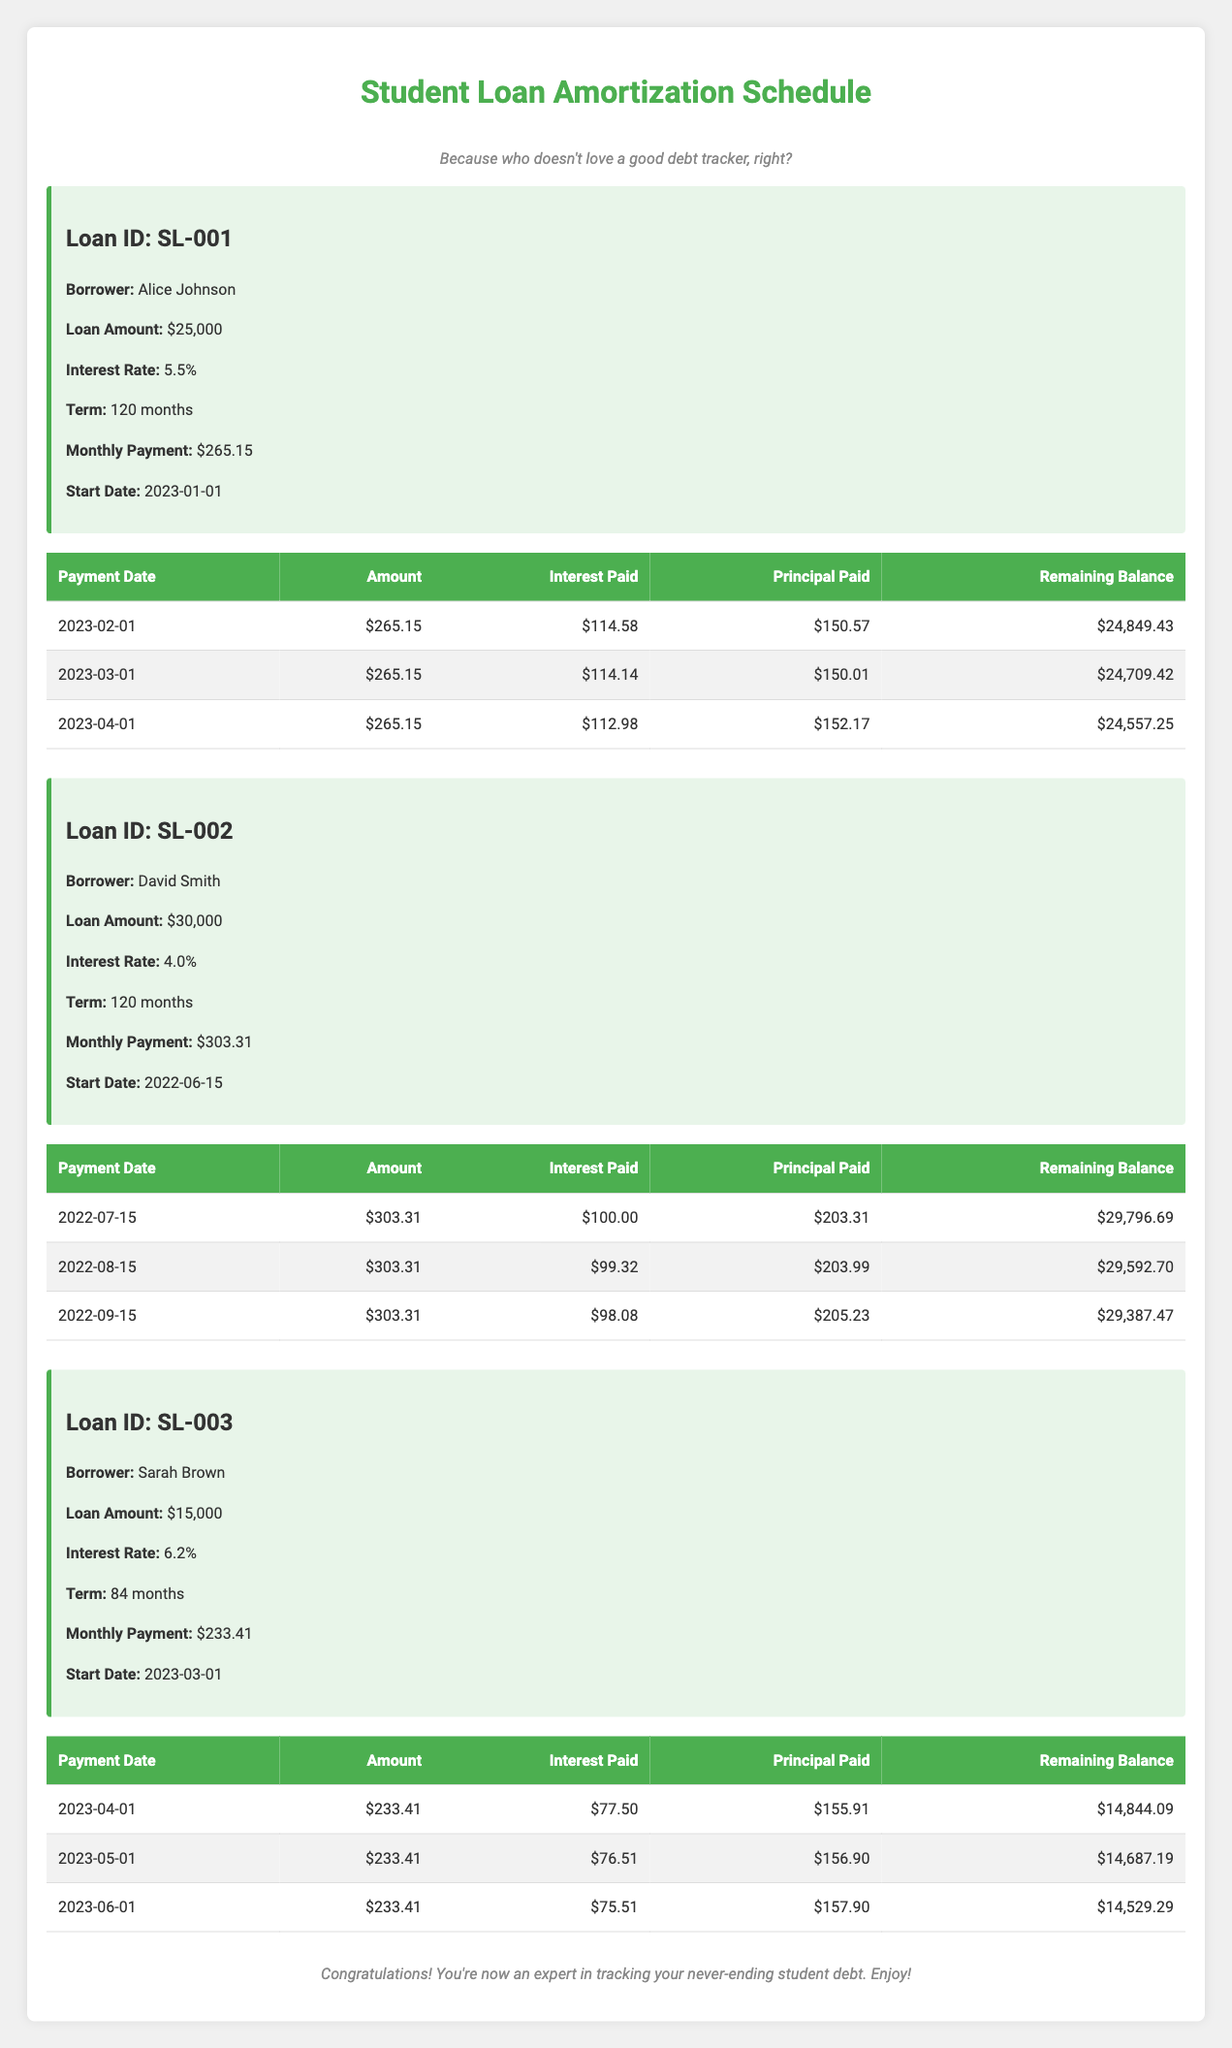What is the loan amount for Alice Johnson? The loan amount is specified in the loan details for Alice Johnson, which states that the loan amount is $25,000.
Answer: 25000 How much is the monthly payment for David Smith? The monthly payment for David Smith is listed under his loan information and is $303.31.
Answer: 303.31 What was the interest paid by Sarah Brown on her first payment? In Sarah Brown's first payment history entry, it shows the interest paid on 2023-04-01 as $77.50.
Answer: 77.50 How much principal did Alice Johnson pay in her second payment? Alice Johnson's second payment on 2023-03-01 shows that she paid $150.01 towards the principal.
Answer: 150.01 Is the interest rate for David Smith higher than that for Alice Johnson? David Smith's interest rate is 4.0%, while Alice Johnson's is 5.5%. Since 4.0% is less than 5.5%, the statement is false.
Answer: No What is the remaining balance for Sarah Brown after her second payment? After Sarah Brown's second payment on 2023-05-01, the remaining balance is listed as $14,687.19, which is the result of her previous balance minus the principal paid.
Answer: 14687.19 How much total interest did Alice Johnson pay over her first three payments? To find the total interest paid, sum the interest amounts from her first three payments: $114.58 + $114.14 + $112.98 = $341.70.
Answer: 341.70 If Sarah Brown made one more payment, what would her remaining balance be assuming she pays the same amount as her last payment? The last payment amount is $233.41. If she pays this again, we add $233.41 to her remaining balance of $14,529.29. The new balance would be $14,529.29 - $233.41 = $14,295.88.
Answer: 14295.88 What is the average interest paid on David Smith's first three payments? The interest amounts paid are $100.00, $99.32, and $98.08. Summing these gives $297.40. Dividing by the number of payments (3) gives an average of $99.13.
Answer: 99.13 What was the last payment date for Alice Johnson? The last payment date listed for Alice Johnson is the last row in her payment history, which is on 2023-04-01.
Answer: 2023-04-01 